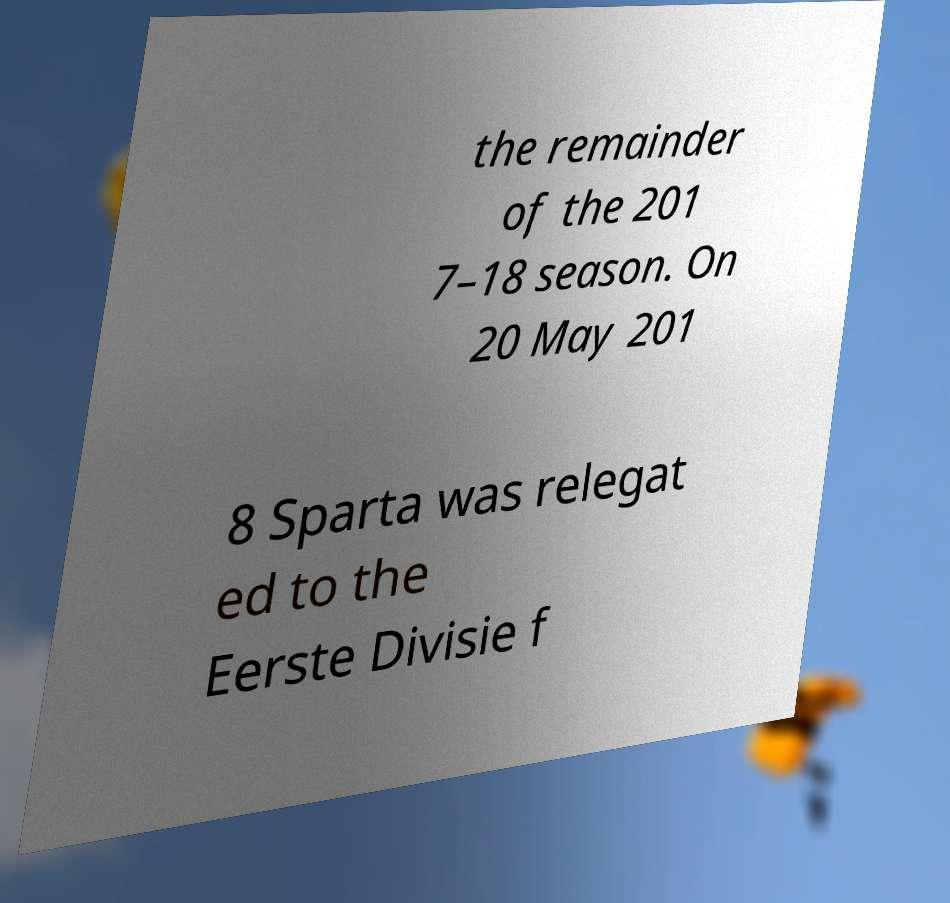Can you accurately transcribe the text from the provided image for me? the remainder of the 201 7–18 season. On 20 May 201 8 Sparta was relegat ed to the Eerste Divisie f 